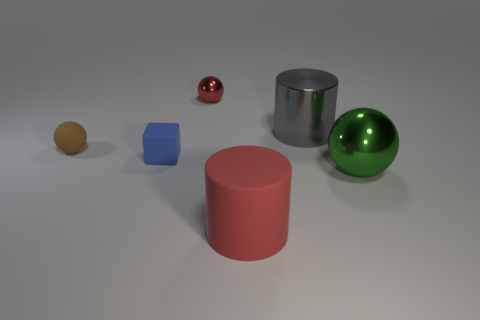How many rubber things are the same shape as the big gray shiny thing? 1 